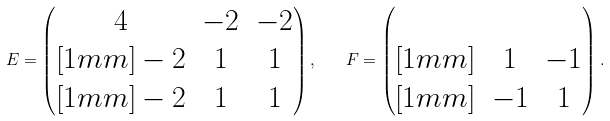<formula> <loc_0><loc_0><loc_500><loc_500>E = \begin{pmatrix} 4 & - 2 & - 2 \\ [ 1 m m ] - 2 & 1 & 1 \\ [ 1 m m ] - 2 & 1 & 1 \end{pmatrix} , \quad F = \begin{pmatrix} & & \\ [ 1 m m ] & 1 & - 1 \\ [ 1 m m ] & - 1 & 1 \end{pmatrix} .</formula> 